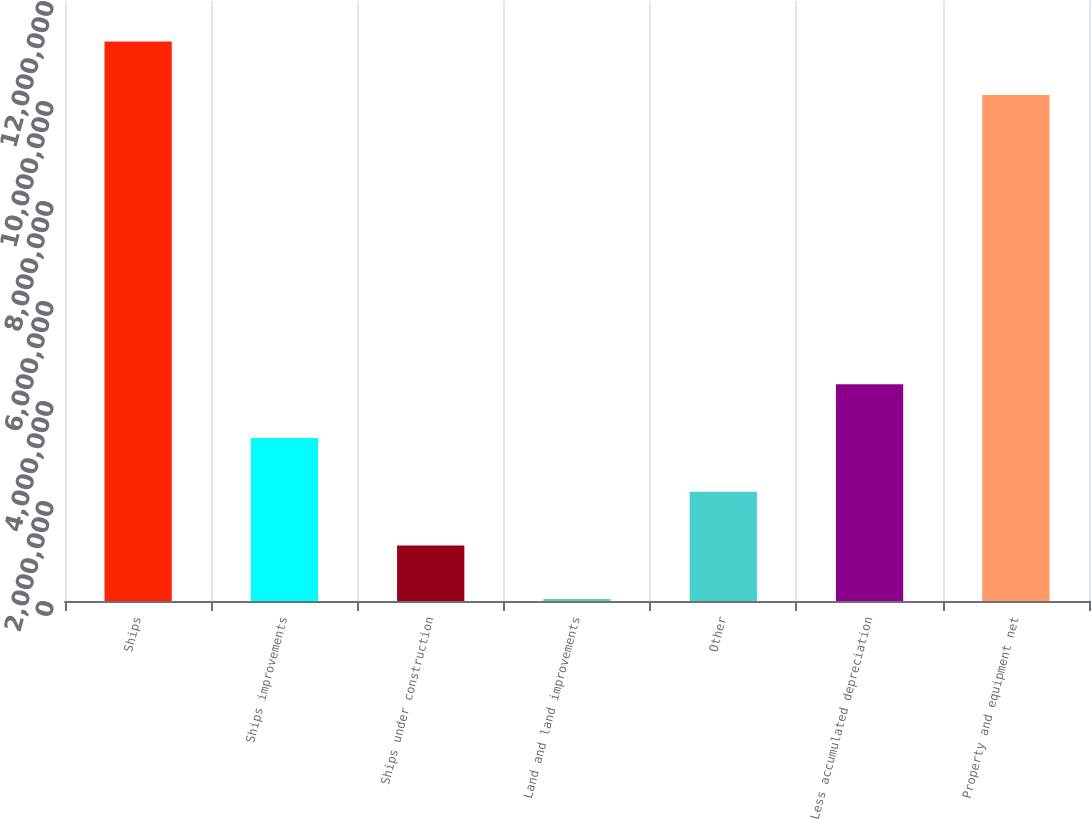<chart> <loc_0><loc_0><loc_500><loc_500><bar_chart><fcel>Ships<fcel>Ships improvements<fcel>Ships under construction<fcel>Land and land improvements<fcel>Other<fcel>Less accumulated depreciation<fcel>Property and equipment net<nl><fcel>1.11921e+07<fcel>3.26079e+06<fcel>1.11195e+06<fcel>37535<fcel>2.18637e+06<fcel>4.3352e+06<fcel>1.01177e+07<nl></chart> 